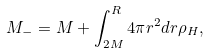<formula> <loc_0><loc_0><loc_500><loc_500>M _ { - } = M + \int _ { 2 M } ^ { R } 4 \pi r ^ { 2 } d r \rho _ { H } ,</formula> 